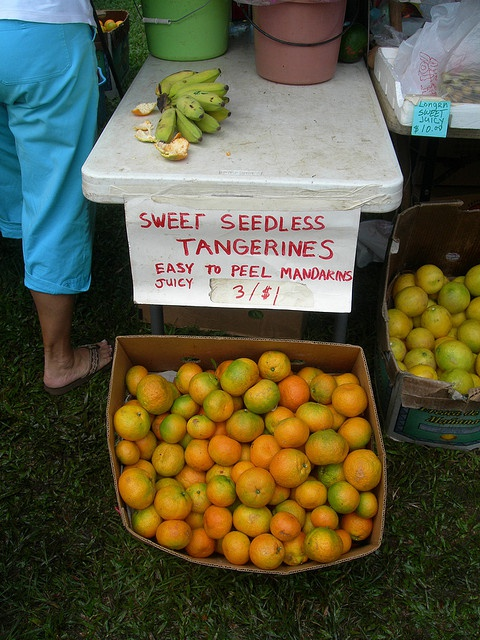Describe the objects in this image and their specific colors. I can see orange in lightblue, olive, and orange tones, dining table in lightblue, darkgray, lightgray, and gray tones, people in lightblue and teal tones, banana in lightblue and olive tones, and orange in lightblue, olive, black, and darkgreen tones in this image. 